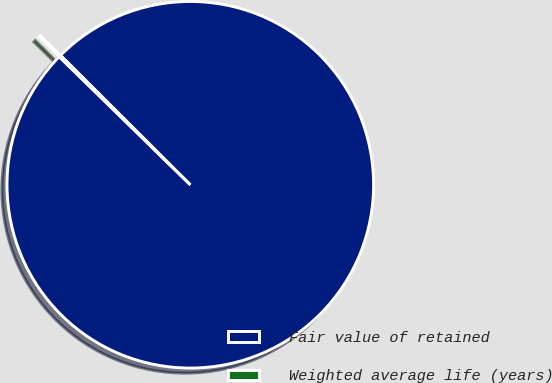Convert chart to OTSL. <chart><loc_0><loc_0><loc_500><loc_500><pie_chart><fcel>Fair value of retained<fcel>Weighted average life (years)<nl><fcel>99.83%<fcel>0.17%<nl></chart> 